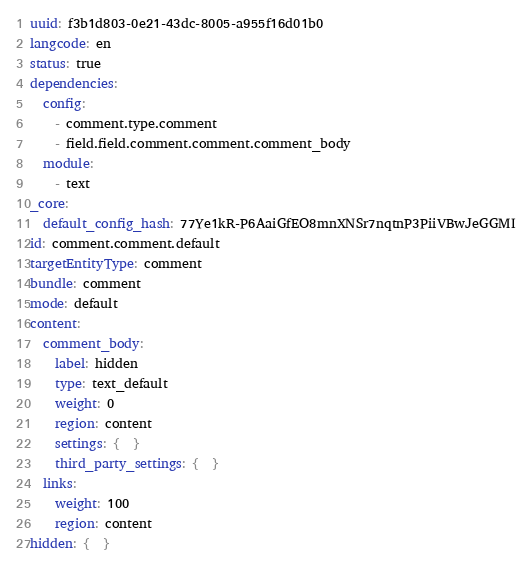Convert code to text. <code><loc_0><loc_0><loc_500><loc_500><_YAML_>uuid: f3b1d803-0e21-43dc-8005-a955f16d01b0
langcode: en
status: true
dependencies:
  config:
    - comment.type.comment
    - field.field.comment.comment.comment_body
  module:
    - text
_core:
  default_config_hash: 77Ye1kR-P6AaiGfEO8mnXNSr7nqtnP3PiiVBwJeGGMI
id: comment.comment.default
targetEntityType: comment
bundle: comment
mode: default
content:
  comment_body:
    label: hidden
    type: text_default
    weight: 0
    region: content
    settings: {  }
    third_party_settings: {  }
  links:
    weight: 100
    region: content
hidden: {  }
</code> 